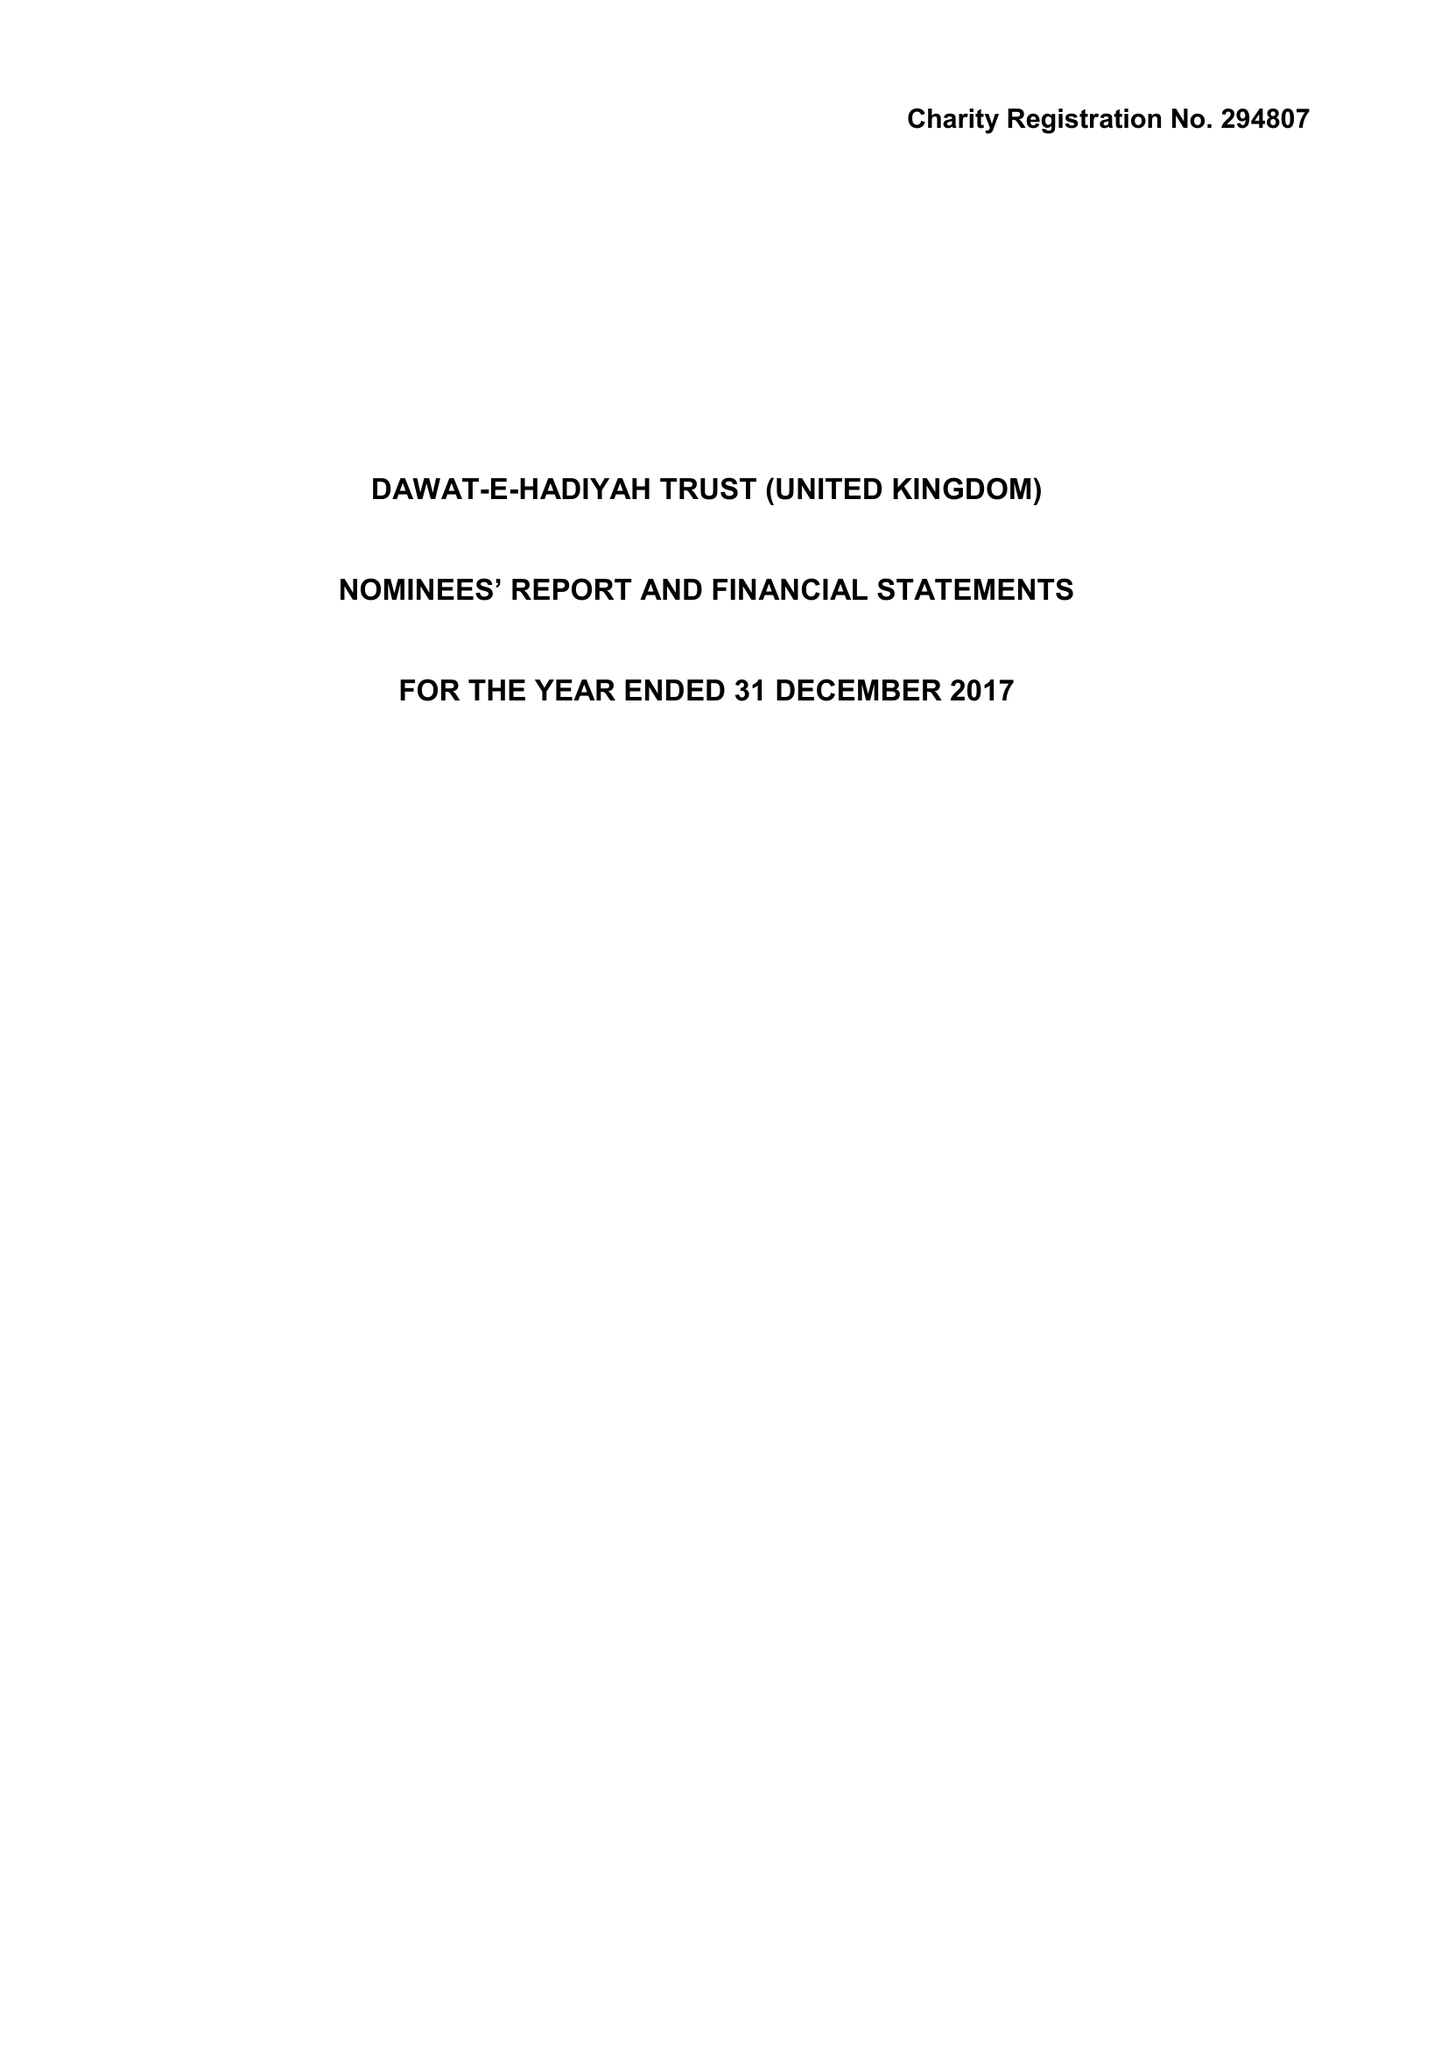What is the value for the report_date?
Answer the question using a single word or phrase. 2017-12-31 